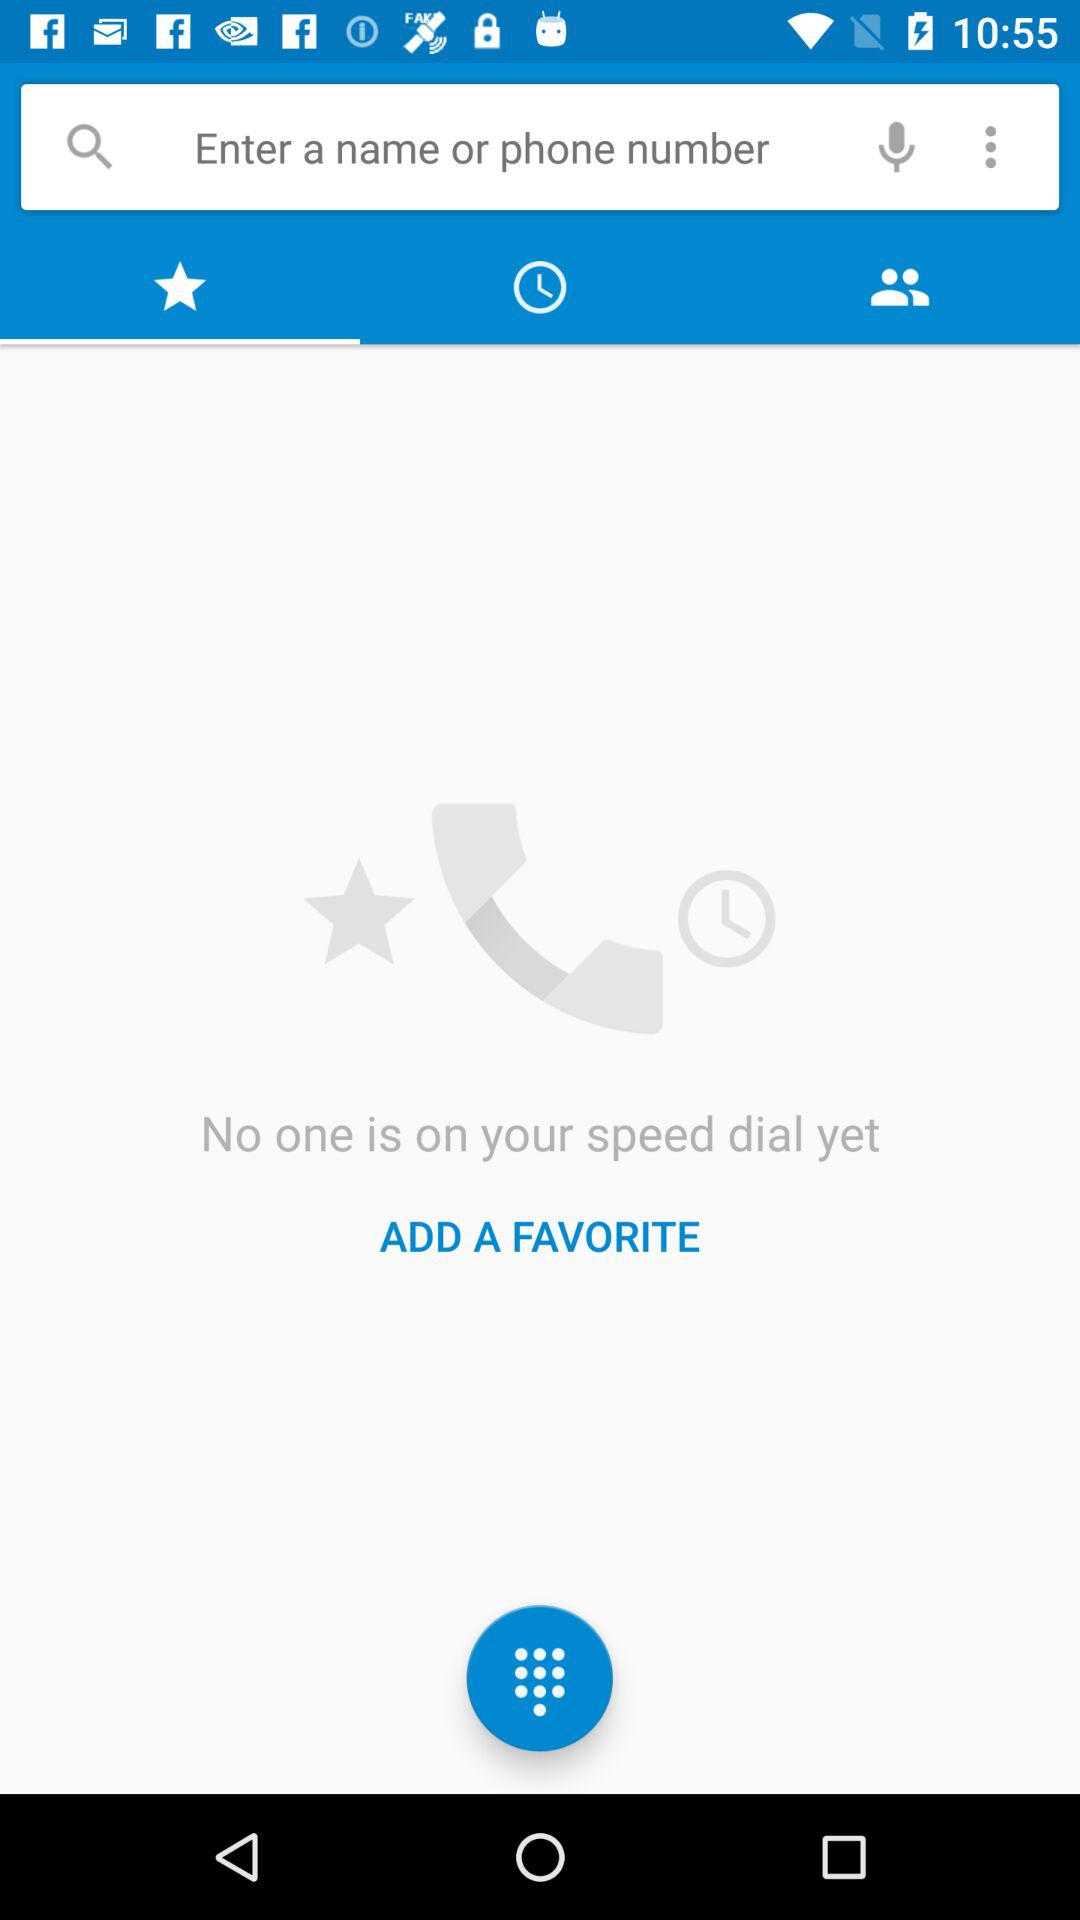How many people are on the speed dial?
Answer the question using a single word or phrase. 0 